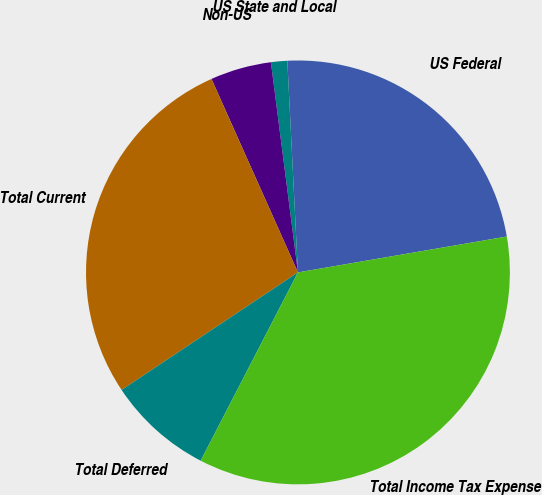Convert chart. <chart><loc_0><loc_0><loc_500><loc_500><pie_chart><fcel>US Federal<fcel>US State and Local<fcel>Non-US<fcel>Total Current<fcel>Total Deferred<fcel>Total Income Tax Expense<nl><fcel>23.09%<fcel>1.24%<fcel>4.65%<fcel>27.67%<fcel>8.05%<fcel>35.3%<nl></chart> 